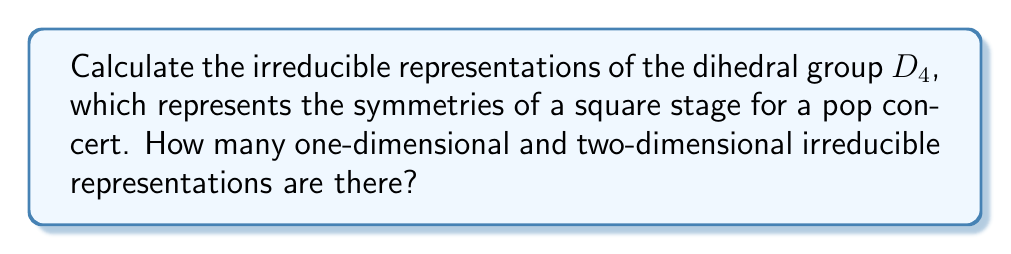Provide a solution to this math problem. Let's approach this step-by-step:

1) The dihedral group $D_4$ has 8 elements: 4 rotations (including identity) and 4 reflections.

2) To find the irreducible representations, we first need to find the conjugacy classes:
   - $\{e\}$ (identity)
   - $\{r^2\}$ (180° rotation)
   - $\{r, r^3\}$ (90° and 270° rotations)
   - $\{s, sr^2\}$ (reflections across diagonals)
   - $\{sr, sr^3\}$ (reflections across midlines)

3) The number of irreducible representations is equal to the number of conjugacy classes, which is 5.

4) The sum of the squares of the dimensions of the irreducible representations must equal the order of the group:

   $$d_1^2 + d_2^2 + d_3^2 + d_4^2 + d_5^2 = 8$$

5) We know that $D_4$ has 4 one-dimensional representations:
   - The trivial representation
   - Three representations where reflections act as -1 and rotations as either 1 or -1

6) This leaves one two-dimensional representation to satisfy the equation in step 4:

   $$1^2 + 1^2 + 1^2 + 1^2 + 2^2 = 8$$

Therefore, $D_4$ has 4 one-dimensional irreducible representations and 1 two-dimensional irreducible representation.
Answer: 4 one-dimensional, 1 two-dimensional 